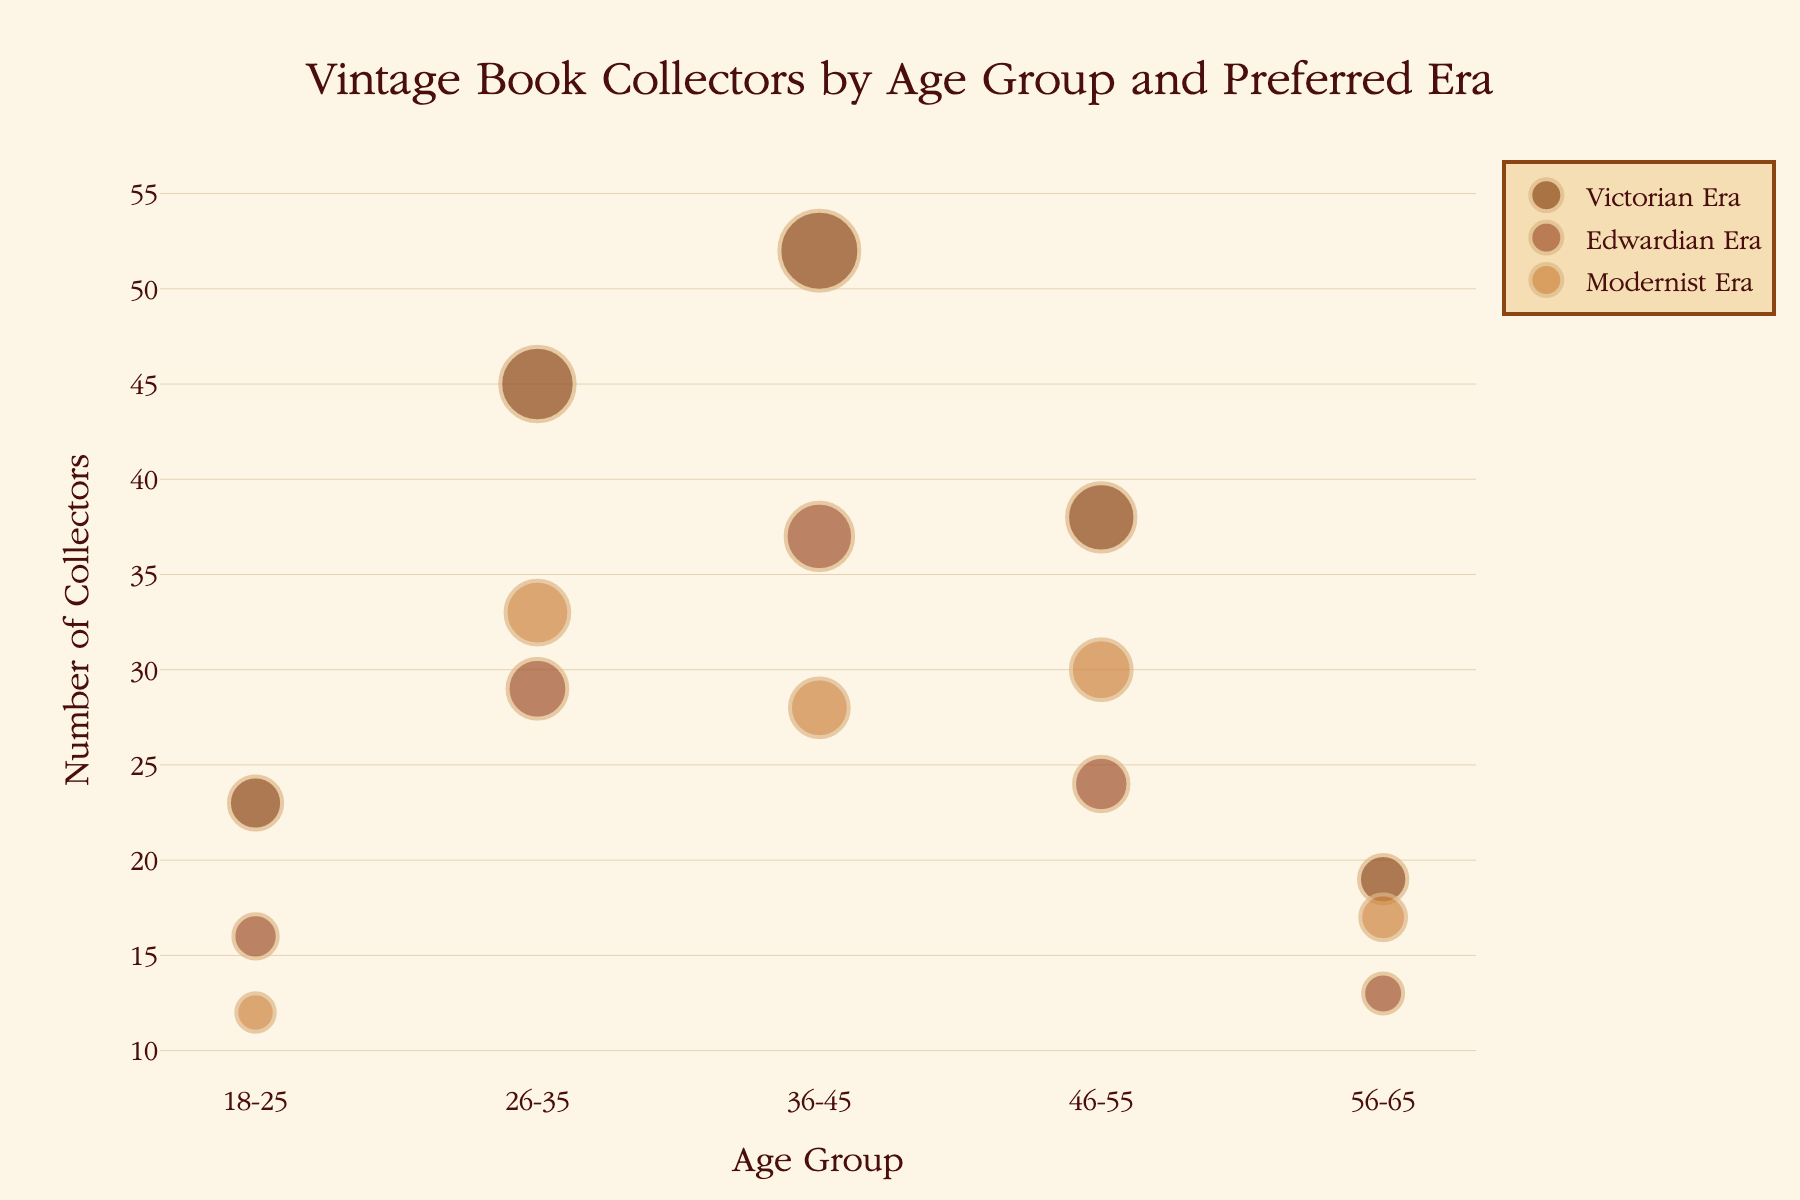What is the most popular book era among collectors aged 26-35? The highest number of collectors in the 26-35 age group is 45, which corresponds to the Victorian Era.
Answer: Victorian Era Which age group has the fewest collectors interested in the Edwardian Era? Among the age groups, the 56-65 group has the fewest collectors interested in the Edwardian Era, with a count of 13.
Answer: 56-65 What is the total number of collectors interested in the Victorian Era across all age groups? Summing up the number of collectors interested in the Victorian Era: 23 (18-25) + 45 (26-35) + 52 (36-45) + 38 (46-55) + 19 (56-65) = 177.
Answer: 177 Which age group has the highest number of collectors for the Modernist Era? The 26-35 age group has the highest number of collectors for the Modernist Era, with a count of 33.
Answer: 26-35 What is the difference in the number of collectors interested in the Edwardian Era between the 36-45 and 46-55 age groups? The number of collectors interested in the Edwardian Era is 37 for the 36-45 group and 24 for the 46-55 group. The difference is 37 - 24 = 13.
Answer: 13 Which book era has the least popularity among the 18-25 age group? The least popular book era among the 18-25 age group is the Modernist Era, with 12 collectors.
Answer: Modernist Era What is the average number of collectors in the 46-55 age group across all book eras? The total number of collectors in the 46-55 age group is 38 (Victorian) + 24 (Edwardian) + 30 (Modernist) = 92. There are 3 book eras, so the average is 92/3 ≈ 30.67.
Answer: 30.67 How does the number of collectors in the 26-35 age group compare between the Victorian and Modernist eras? In the 26-35 age group, there are 45 collectors for the Victorian Era and 33 for the Modernist Era. The Victorian Era has more collectors by 45 - 33 = 12.
Answer: Victorian Era by 12 What is the sum of collectors interested in the Edwardian Era for the 18-25 and 56-65 age groups? Adding the number of collectors interested in the Edwardian Era: 16 (18-25) + 13 (56-65) = 29.
Answer: 29 